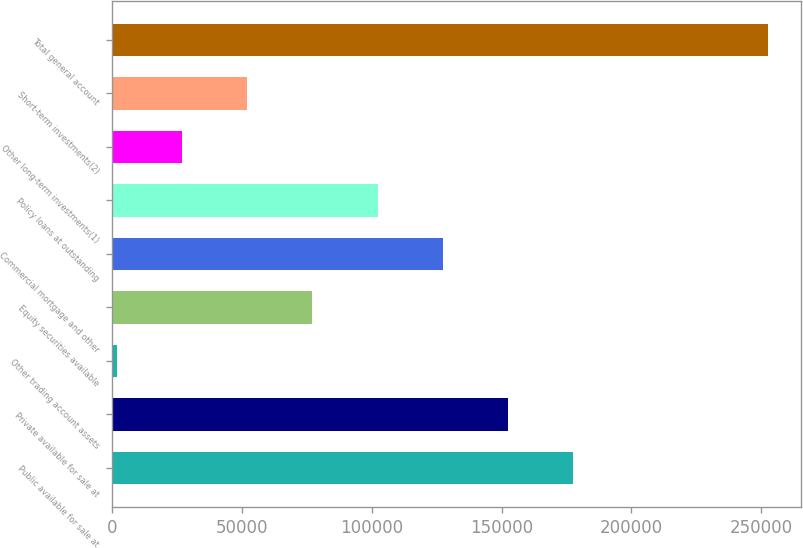Convert chart. <chart><loc_0><loc_0><loc_500><loc_500><bar_chart><fcel>Public available for sale at<fcel>Private available for sale at<fcel>Other trading account assets<fcel>Equity securities available<fcel>Commercial mortgage and other<fcel>Policy loans at outstanding<fcel>Other long-term investments(1)<fcel>Short-term investments(2)<fcel>Total general account<nl><fcel>177505<fcel>152402<fcel>1783<fcel>77092.6<fcel>127299<fcel>102196<fcel>26886.2<fcel>51989.4<fcel>252815<nl></chart> 